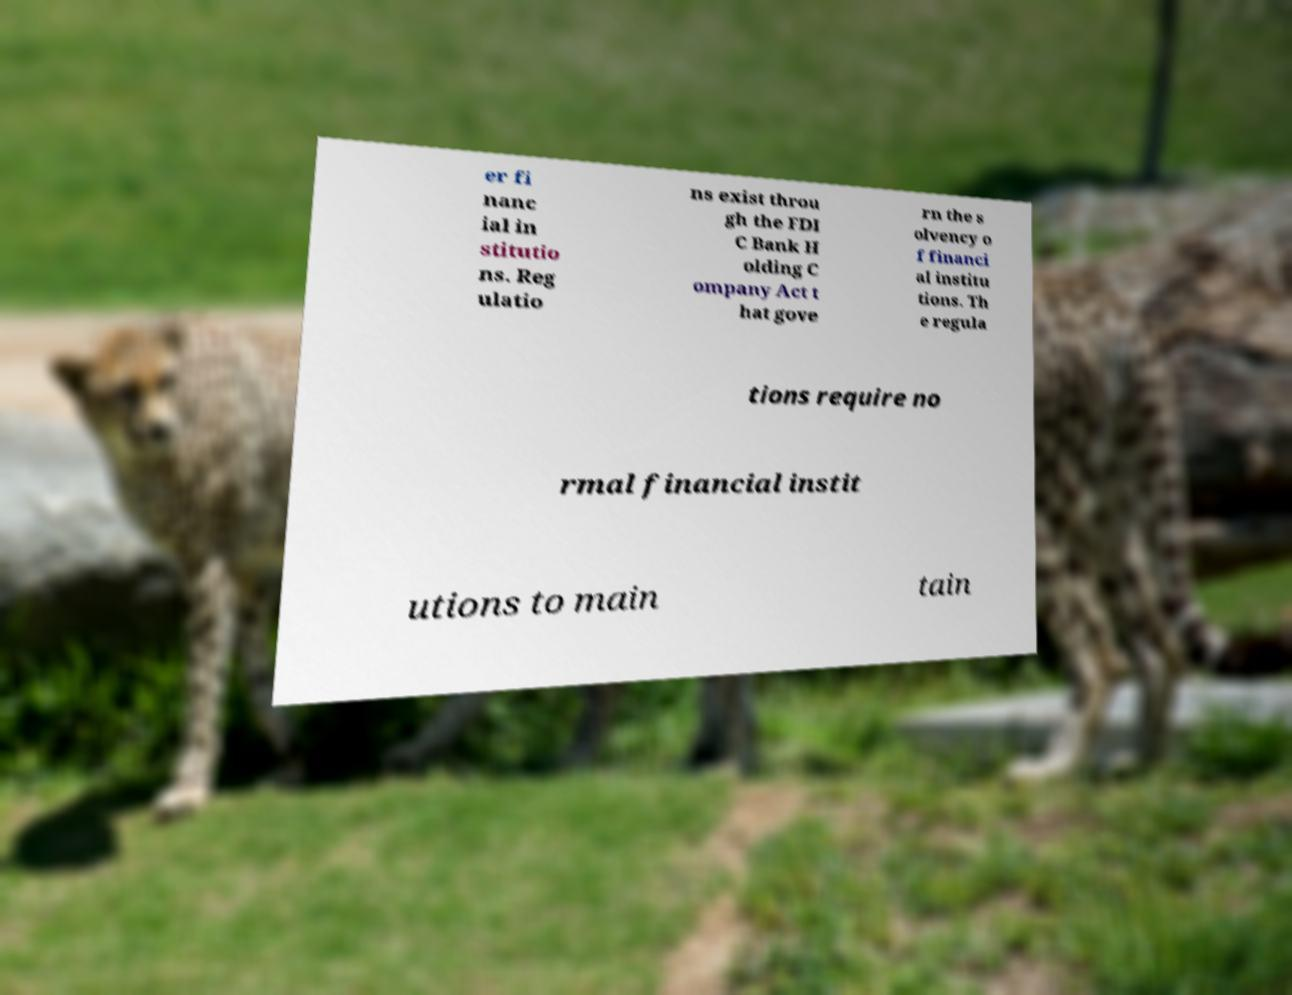Can you read and provide the text displayed in the image?This photo seems to have some interesting text. Can you extract and type it out for me? er fi nanc ial in stitutio ns. Reg ulatio ns exist throu gh the FDI C Bank H olding C ompany Act t hat gove rn the s olvency o f financi al institu tions. Th e regula tions require no rmal financial instit utions to main tain 